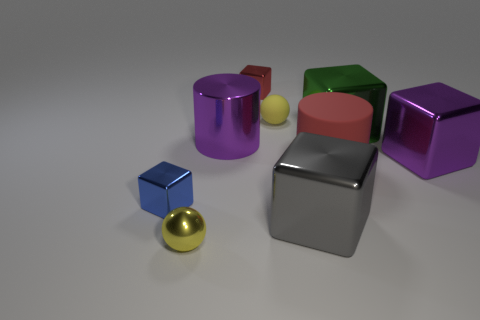Subtract all big shiny cubes. How many cubes are left? 2 Subtract all cylinders. How many objects are left? 7 Add 2 large green shiny cubes. How many large green shiny cubes are left? 3 Add 6 blue things. How many blue things exist? 7 Subtract all red cylinders. How many cylinders are left? 1 Subtract 0 yellow blocks. How many objects are left? 9 Subtract 5 cubes. How many cubes are left? 0 Subtract all purple cylinders. Subtract all green blocks. How many cylinders are left? 1 Subtract all green matte balls. Subtract all big green metal things. How many objects are left? 8 